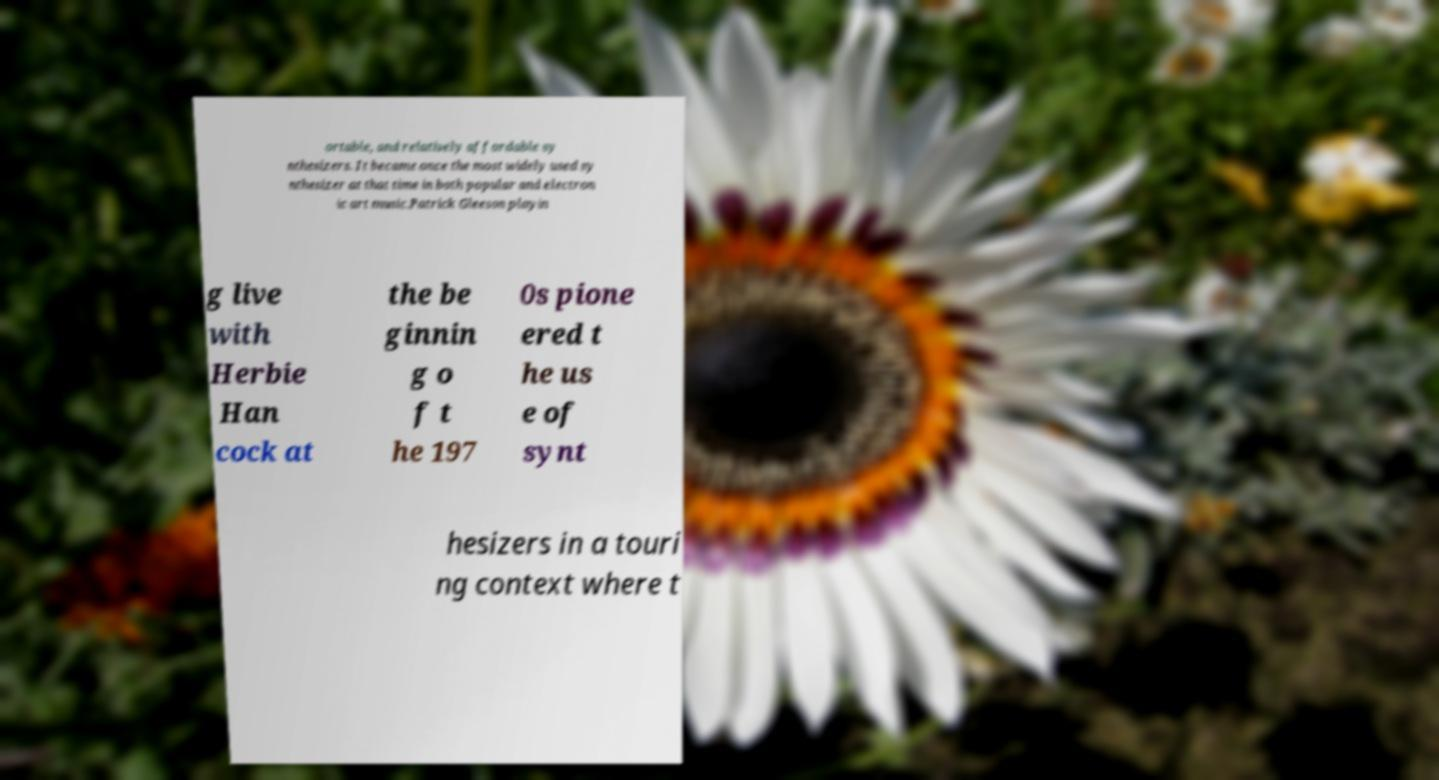Please identify and transcribe the text found in this image. ortable, and relatively affordable sy nthesizers. It became once the most widely used sy nthesizer at that time in both popular and electron ic art music.Patrick Gleeson playin g live with Herbie Han cock at the be ginnin g o f t he 197 0s pione ered t he us e of synt hesizers in a touri ng context where t 